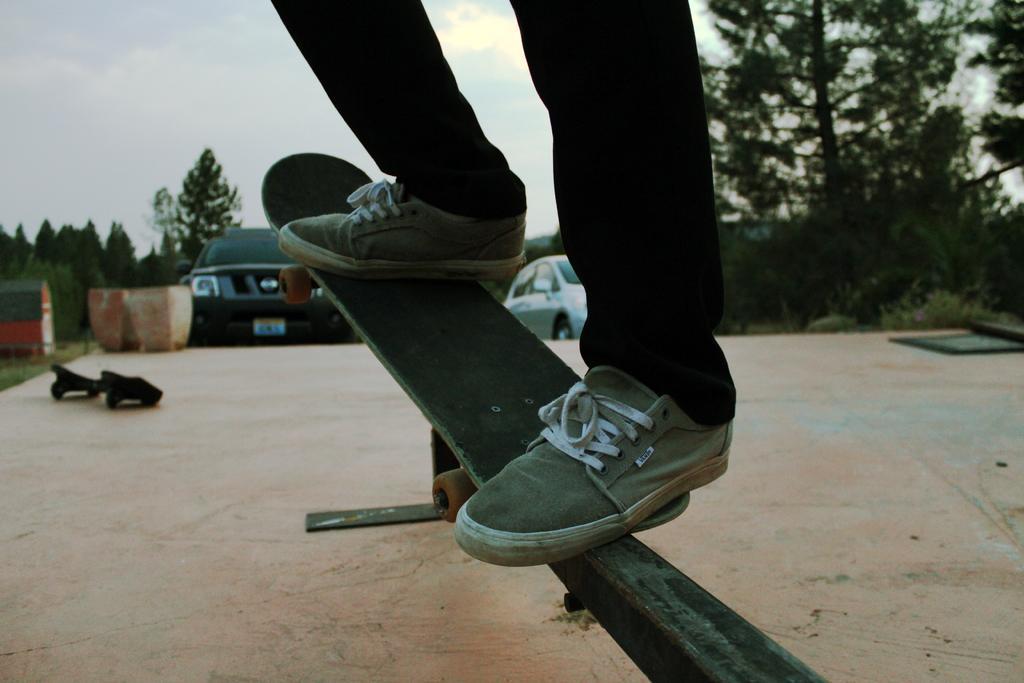Can you describe this image briefly? In this image we can see a person standing on a skateboard which is on a metal object. There are trees and cars in the background and the sky is at the top of this image. 